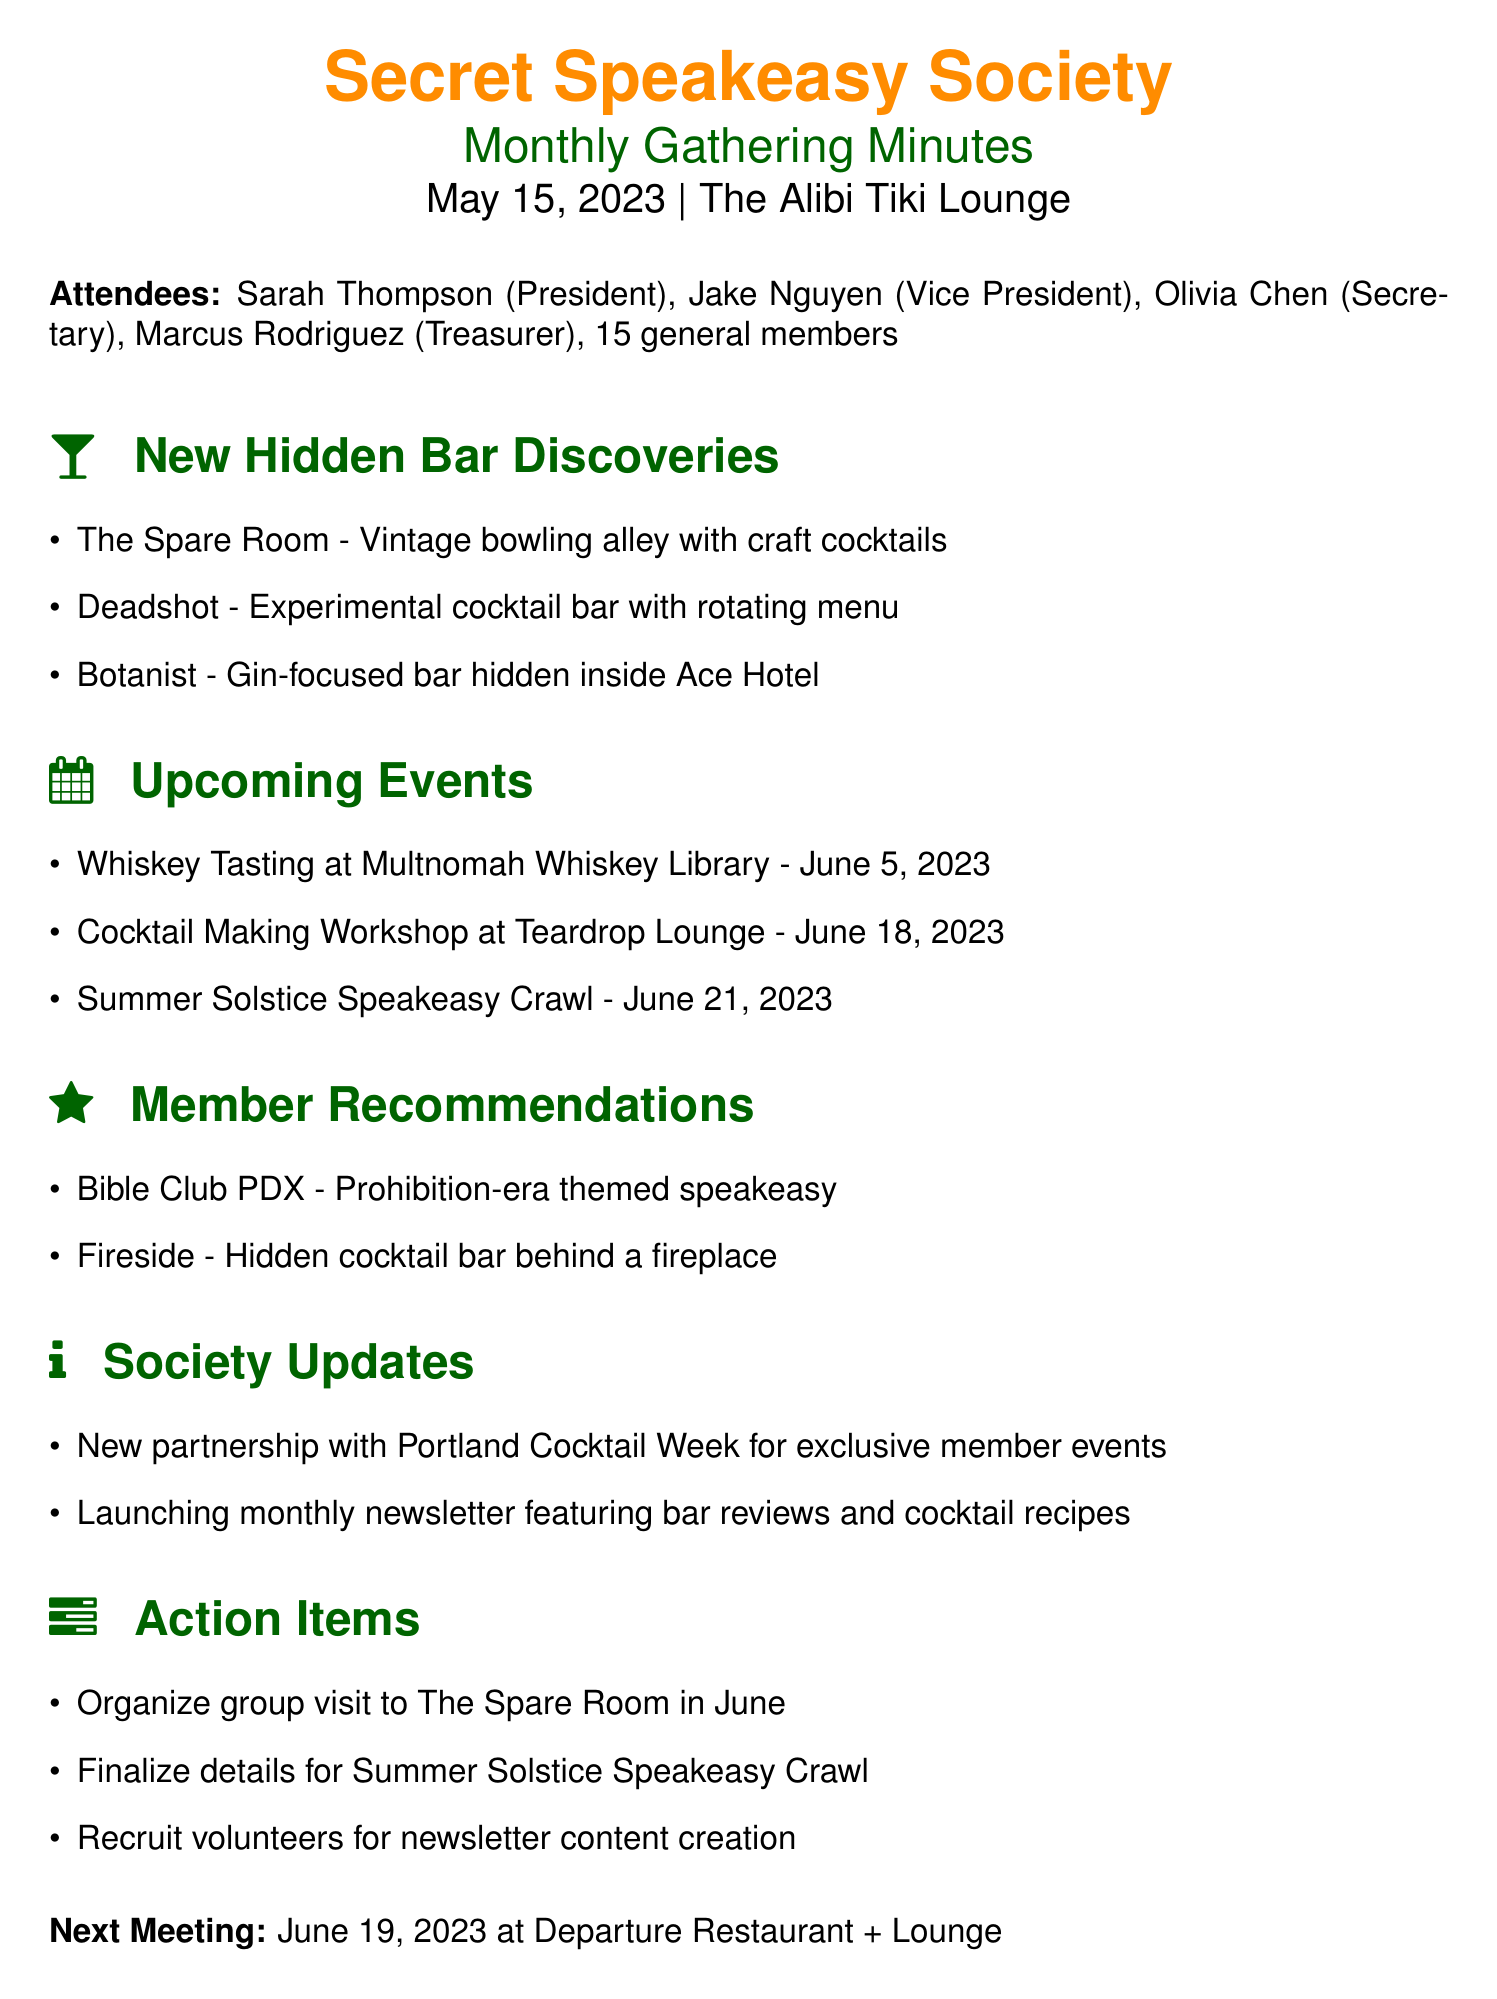What is the date of the next meeting? The next meeting is scheduled in the document with a specific date listed at the end.
Answer: June 19, 2023 Where was the monthly gathering held? The location of the meeting is explicitly mentioned at the beginning of the document after the date.
Answer: The Alibi Tiki Lounge What is the name of the President? The document lists the attendees, providing names and roles including the President's name.
Answer: Sarah Thompson What is one new hidden bar mentioned in the meeting? The document details new hidden bar discoveries, listing specific names.
Answer: The Spare Room When is the Whiskey Tasting event? This event is part of the upcoming events section, providing a specific date.
Answer: June 5, 2023 How many general members attended the meeting? The document includes the number of general members present in the attendees' list.
Answer: 15 What theme does Bible Club PDX have? This bar is mentioned in the member recommendations section, specifying its theme.
Answer: Prohibition-era What action item involves the Summer Solstice? The action items section lists specific tasks related to the upcoming events, including one that pertains to this event.
Answer: Finalize details for Summer Solstice Speakeasy Crawl What new partnership was announced during the meeting? The society updates include a specific new partnership mentioned in that section.
Answer: Portland Cocktail Week 